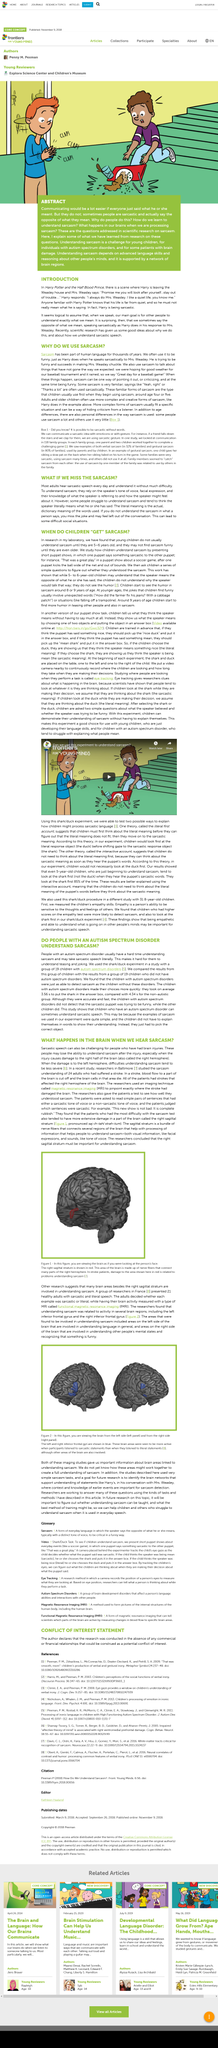Mention a couple of crucial points in this snapshot. Recent scientific research has yielded valuable insights into the reasons behind our behavior and the understanding of sarcastic speech. The color of the child's shirt who is clapping is blue. When we speak, it is logical to assume that our main goal is for other people to understand exactly what we mean. Adults understand sarcasm by relying on the speaker's tone of voice, facial expression, and their knowledge of the speaker's reference and attitude towards the subject matter. The topic of study in sarcasm is sarcasm. 